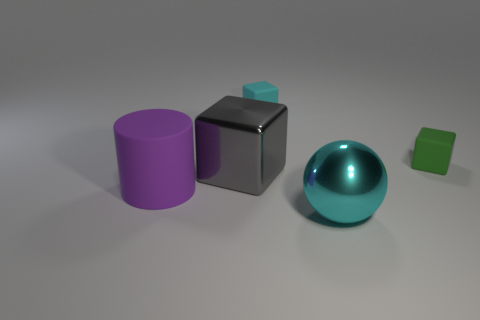There is a block that is on the right side of the small cyan cube; what is its size?
Your response must be concise. Small. Is the shape of the big purple object the same as the big gray object?
Keep it short and to the point. No. What number of small things are either yellow metallic spheres or cyan rubber blocks?
Offer a terse response. 1. There is a purple object; are there any cylinders on the right side of it?
Give a very brief answer. No. Are there an equal number of large rubber objects on the right side of the cyan cube and large purple metal cubes?
Make the answer very short. Yes. What size is the gray shiny object that is the same shape as the green object?
Provide a short and direct response. Large. Do the green object and the rubber thing that is behind the tiny green cube have the same shape?
Your answer should be compact. Yes. How big is the matte cube that is on the right side of the cube that is behind the green cube?
Give a very brief answer. Small. Are there the same number of metal blocks that are behind the tiny cyan rubber cube and gray things that are in front of the large purple matte cylinder?
Ensure brevity in your answer.  Yes. What is the color of the other large object that is the same shape as the green thing?
Offer a terse response. Gray. 